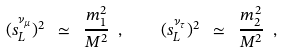Convert formula to latex. <formula><loc_0><loc_0><loc_500><loc_500>( s ^ { \nu _ { \mu } } _ { L } ) ^ { 2 } \ \simeq \ \frac { m _ { 1 } ^ { 2 } } { M ^ { 2 } } \ , \quad ( s ^ { \nu _ { \tau } } _ { L } ) ^ { 2 } \ \simeq \ \frac { m _ { 2 } ^ { 2 } } { M ^ { 2 } } \ ,</formula> 